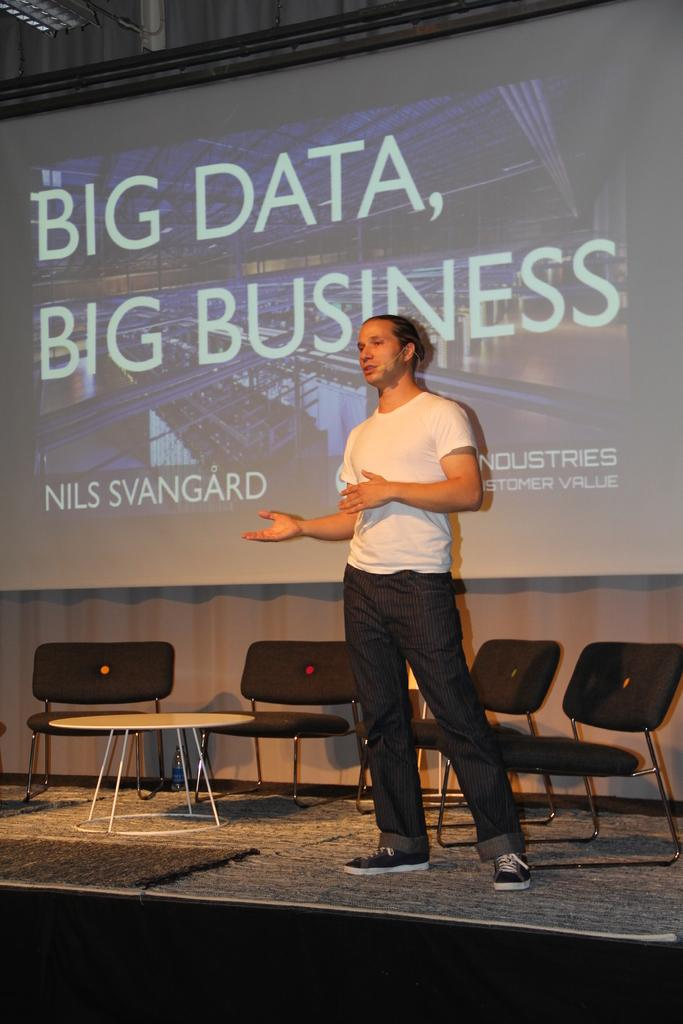What is the main subject of the image? There is a person in the image. What is the person wearing? The person is wearing a white dress. Where is the person located in the image? The person is standing on a stage. What can be seen in the background of the image? There are chairs, a table, and a projector screen in the background of the image. How does the person express their dislike for the twig in the image? There is no twig present in the image, and therefore no such expression can be observed. 